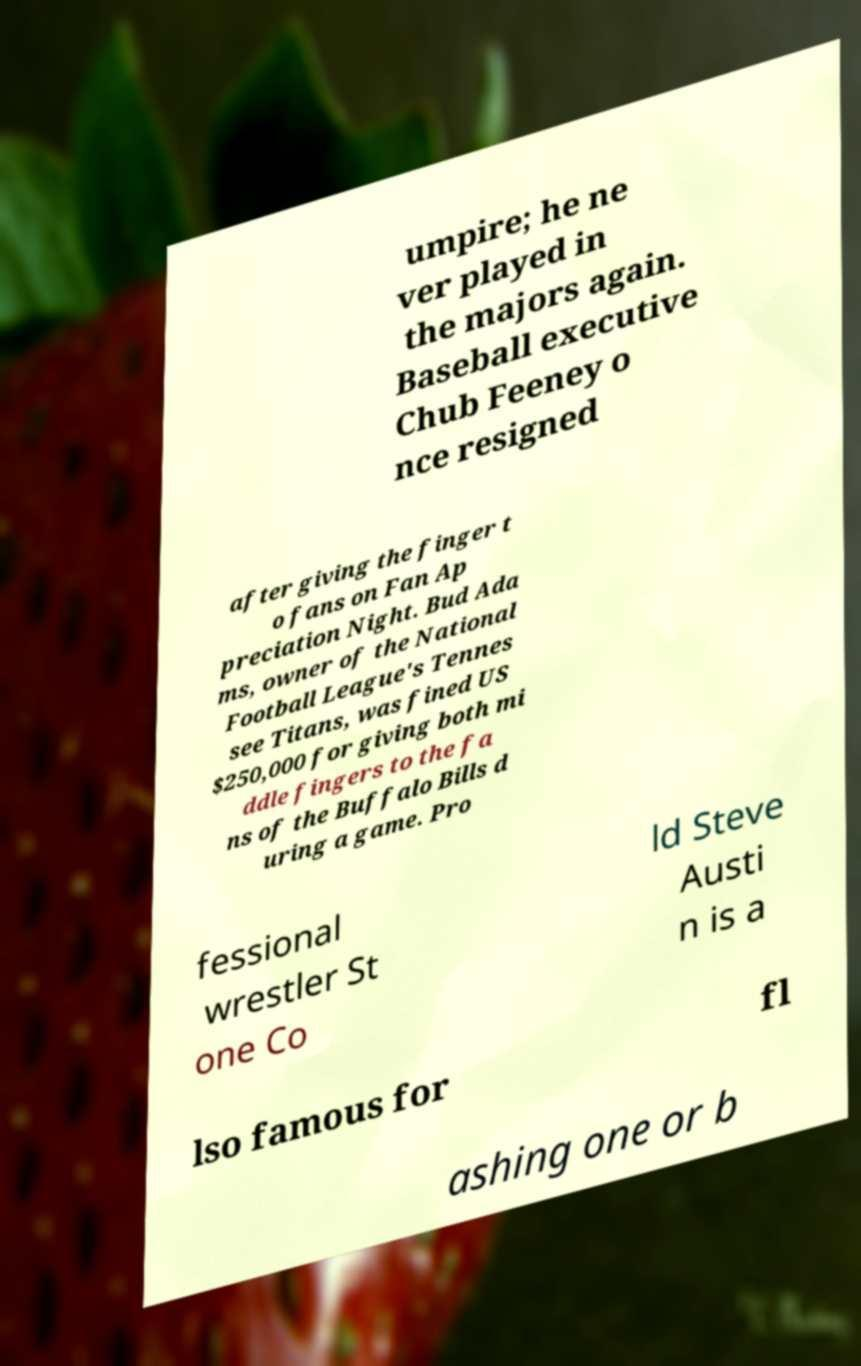For documentation purposes, I need the text within this image transcribed. Could you provide that? umpire; he ne ver played in the majors again. Baseball executive Chub Feeney o nce resigned after giving the finger t o fans on Fan Ap preciation Night. Bud Ada ms, owner of the National Football League's Tennes see Titans, was fined US $250,000 for giving both mi ddle fingers to the fa ns of the Buffalo Bills d uring a game. Pro fessional wrestler St one Co ld Steve Austi n is a lso famous for fl ashing one or b 